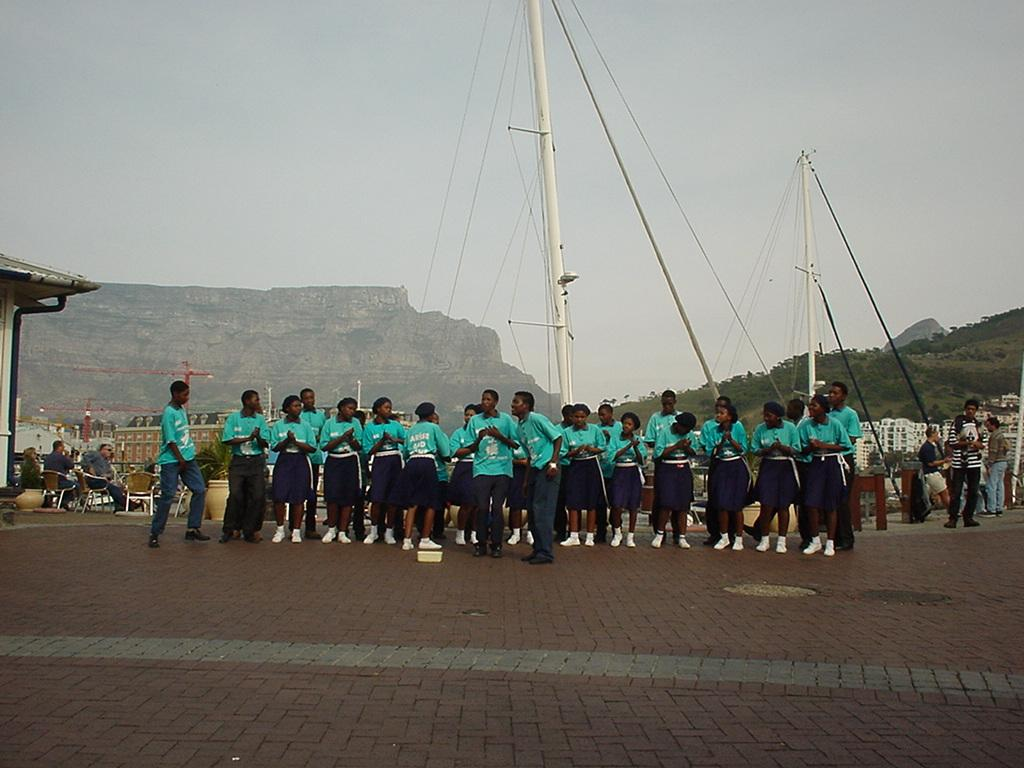Who or what can be seen in the image? There are people in the image. What objects are present with the people? There are plants with pots in the image. Where is the scene taking place? The scene is on a roof top in the image. What structures are visible in the image? There are poles and ropes in the image. What can be seen in the background of the image? There are buildings, trees, and sky visible in the background of the image. What type of unit is being measured by the kitten in the image? There is no kitten present in the image, and therefore no unit measurement can be observed. What color is the cap worn by the person in the image? There is no person wearing a cap in the image. 